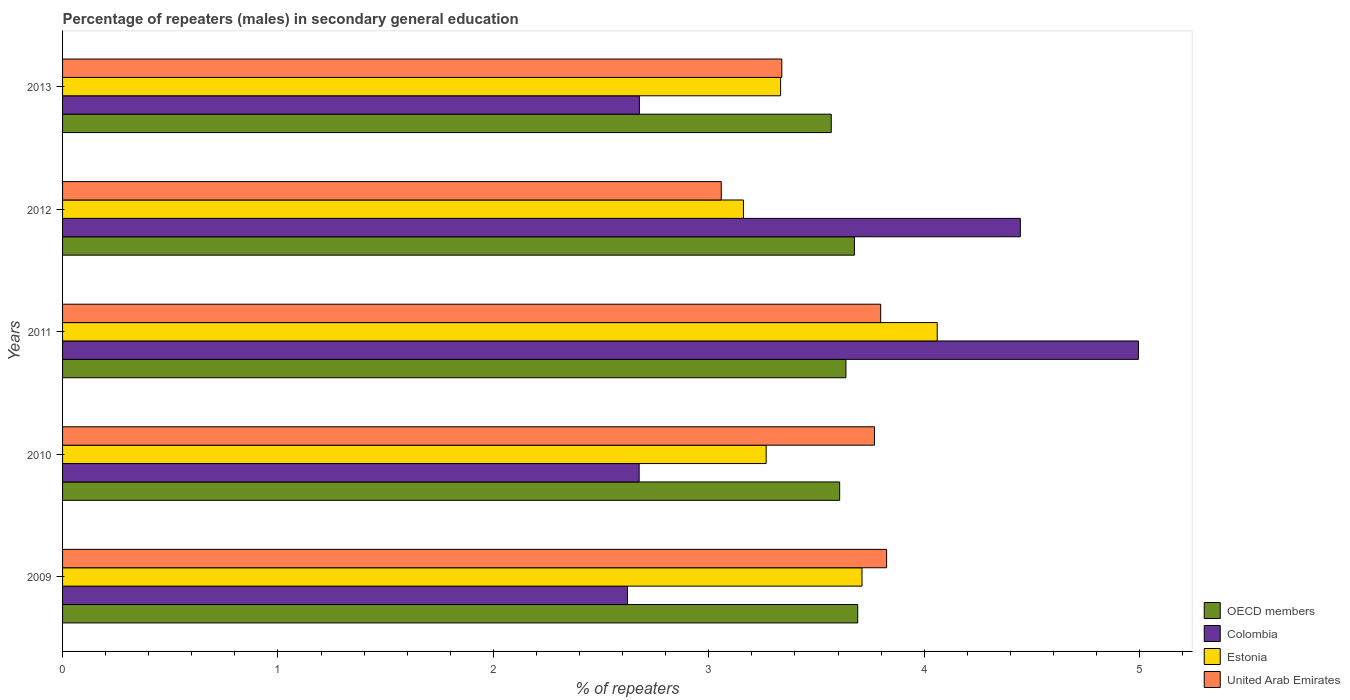How many groups of bars are there?
Offer a terse response. 5. Are the number of bars per tick equal to the number of legend labels?
Give a very brief answer. Yes. How many bars are there on the 2nd tick from the bottom?
Your answer should be compact. 4. What is the label of the 5th group of bars from the top?
Give a very brief answer. 2009. In how many cases, is the number of bars for a given year not equal to the number of legend labels?
Your response must be concise. 0. What is the percentage of male repeaters in United Arab Emirates in 2011?
Provide a short and direct response. 3.8. Across all years, what is the maximum percentage of male repeaters in OECD members?
Your response must be concise. 3.69. Across all years, what is the minimum percentage of male repeaters in Estonia?
Make the answer very short. 3.16. In which year was the percentage of male repeaters in Colombia maximum?
Ensure brevity in your answer.  2011. In which year was the percentage of male repeaters in United Arab Emirates minimum?
Keep it short and to the point. 2012. What is the total percentage of male repeaters in Colombia in the graph?
Make the answer very short. 17.42. What is the difference between the percentage of male repeaters in Estonia in 2011 and that in 2012?
Give a very brief answer. 0.9. What is the difference between the percentage of male repeaters in Colombia in 2009 and the percentage of male repeaters in Estonia in 2013?
Offer a very short reply. -0.71. What is the average percentage of male repeaters in OECD members per year?
Your answer should be compact. 3.64. In the year 2012, what is the difference between the percentage of male repeaters in Estonia and percentage of male repeaters in OECD members?
Provide a succinct answer. -0.52. In how many years, is the percentage of male repeaters in Colombia greater than 3.6 %?
Provide a succinct answer. 2. What is the ratio of the percentage of male repeaters in OECD members in 2011 to that in 2012?
Give a very brief answer. 0.99. Is the percentage of male repeaters in Estonia in 2009 less than that in 2011?
Keep it short and to the point. Yes. Is the difference between the percentage of male repeaters in Estonia in 2010 and 2013 greater than the difference between the percentage of male repeaters in OECD members in 2010 and 2013?
Offer a very short reply. No. What is the difference between the highest and the second highest percentage of male repeaters in Estonia?
Provide a short and direct response. 0.35. What is the difference between the highest and the lowest percentage of male repeaters in United Arab Emirates?
Offer a very short reply. 0.77. Is the sum of the percentage of male repeaters in Colombia in 2009 and 2011 greater than the maximum percentage of male repeaters in United Arab Emirates across all years?
Keep it short and to the point. Yes. What does the 1st bar from the top in 2009 represents?
Provide a succinct answer. United Arab Emirates. What does the 4th bar from the bottom in 2009 represents?
Your answer should be compact. United Arab Emirates. Are all the bars in the graph horizontal?
Keep it short and to the point. Yes. How many years are there in the graph?
Your answer should be very brief. 5. Are the values on the major ticks of X-axis written in scientific E-notation?
Provide a short and direct response. No. Does the graph contain any zero values?
Your answer should be very brief. No. Does the graph contain grids?
Provide a short and direct response. No. Where does the legend appear in the graph?
Offer a very short reply. Bottom right. How many legend labels are there?
Make the answer very short. 4. How are the legend labels stacked?
Your answer should be very brief. Vertical. What is the title of the graph?
Make the answer very short. Percentage of repeaters (males) in secondary general education. Does "Cameroon" appear as one of the legend labels in the graph?
Provide a succinct answer. No. What is the label or title of the X-axis?
Keep it short and to the point. % of repeaters. What is the label or title of the Y-axis?
Offer a terse response. Years. What is the % of repeaters of OECD members in 2009?
Your answer should be compact. 3.69. What is the % of repeaters in Colombia in 2009?
Ensure brevity in your answer.  2.62. What is the % of repeaters of Estonia in 2009?
Provide a short and direct response. 3.71. What is the % of repeaters in United Arab Emirates in 2009?
Offer a very short reply. 3.83. What is the % of repeaters in OECD members in 2010?
Provide a succinct answer. 3.61. What is the % of repeaters in Colombia in 2010?
Make the answer very short. 2.68. What is the % of repeaters of Estonia in 2010?
Provide a short and direct response. 3.27. What is the % of repeaters in United Arab Emirates in 2010?
Keep it short and to the point. 3.77. What is the % of repeaters of OECD members in 2011?
Ensure brevity in your answer.  3.64. What is the % of repeaters of Colombia in 2011?
Offer a terse response. 4.99. What is the % of repeaters of Estonia in 2011?
Your response must be concise. 4.06. What is the % of repeaters of United Arab Emirates in 2011?
Ensure brevity in your answer.  3.8. What is the % of repeaters in OECD members in 2012?
Your answer should be very brief. 3.68. What is the % of repeaters of Colombia in 2012?
Your answer should be compact. 4.45. What is the % of repeaters in Estonia in 2012?
Make the answer very short. 3.16. What is the % of repeaters in United Arab Emirates in 2012?
Make the answer very short. 3.06. What is the % of repeaters in OECD members in 2013?
Your response must be concise. 3.57. What is the % of repeaters in Colombia in 2013?
Offer a terse response. 2.68. What is the % of repeaters of Estonia in 2013?
Give a very brief answer. 3.33. What is the % of repeaters in United Arab Emirates in 2013?
Provide a short and direct response. 3.34. Across all years, what is the maximum % of repeaters of OECD members?
Offer a terse response. 3.69. Across all years, what is the maximum % of repeaters of Colombia?
Make the answer very short. 4.99. Across all years, what is the maximum % of repeaters of Estonia?
Offer a terse response. 4.06. Across all years, what is the maximum % of repeaters in United Arab Emirates?
Ensure brevity in your answer.  3.83. Across all years, what is the minimum % of repeaters of OECD members?
Your answer should be compact. 3.57. Across all years, what is the minimum % of repeaters in Colombia?
Give a very brief answer. 2.62. Across all years, what is the minimum % of repeaters in Estonia?
Ensure brevity in your answer.  3.16. Across all years, what is the minimum % of repeaters of United Arab Emirates?
Make the answer very short. 3.06. What is the total % of repeaters of OECD members in the graph?
Make the answer very short. 18.18. What is the total % of repeaters in Colombia in the graph?
Your response must be concise. 17.42. What is the total % of repeaters in Estonia in the graph?
Offer a terse response. 17.53. What is the total % of repeaters in United Arab Emirates in the graph?
Provide a succinct answer. 17.79. What is the difference between the % of repeaters of OECD members in 2009 and that in 2010?
Offer a very short reply. 0.08. What is the difference between the % of repeaters of Colombia in 2009 and that in 2010?
Provide a short and direct response. -0.05. What is the difference between the % of repeaters of Estonia in 2009 and that in 2010?
Provide a succinct answer. 0.44. What is the difference between the % of repeaters of United Arab Emirates in 2009 and that in 2010?
Give a very brief answer. 0.06. What is the difference between the % of repeaters in OECD members in 2009 and that in 2011?
Your response must be concise. 0.05. What is the difference between the % of repeaters of Colombia in 2009 and that in 2011?
Keep it short and to the point. -2.37. What is the difference between the % of repeaters of Estonia in 2009 and that in 2011?
Your response must be concise. -0.35. What is the difference between the % of repeaters of United Arab Emirates in 2009 and that in 2011?
Offer a terse response. 0.03. What is the difference between the % of repeaters of OECD members in 2009 and that in 2012?
Your answer should be compact. 0.02. What is the difference between the % of repeaters of Colombia in 2009 and that in 2012?
Your answer should be compact. -1.82. What is the difference between the % of repeaters of Estonia in 2009 and that in 2012?
Give a very brief answer. 0.55. What is the difference between the % of repeaters in United Arab Emirates in 2009 and that in 2012?
Offer a very short reply. 0.77. What is the difference between the % of repeaters in OECD members in 2009 and that in 2013?
Keep it short and to the point. 0.12. What is the difference between the % of repeaters in Colombia in 2009 and that in 2013?
Keep it short and to the point. -0.06. What is the difference between the % of repeaters of Estonia in 2009 and that in 2013?
Provide a short and direct response. 0.38. What is the difference between the % of repeaters in United Arab Emirates in 2009 and that in 2013?
Your response must be concise. 0.49. What is the difference between the % of repeaters of OECD members in 2010 and that in 2011?
Give a very brief answer. -0.03. What is the difference between the % of repeaters in Colombia in 2010 and that in 2011?
Give a very brief answer. -2.32. What is the difference between the % of repeaters in Estonia in 2010 and that in 2011?
Offer a terse response. -0.79. What is the difference between the % of repeaters in United Arab Emirates in 2010 and that in 2011?
Give a very brief answer. -0.03. What is the difference between the % of repeaters of OECD members in 2010 and that in 2012?
Keep it short and to the point. -0.07. What is the difference between the % of repeaters in Colombia in 2010 and that in 2012?
Your response must be concise. -1.77. What is the difference between the % of repeaters of Estonia in 2010 and that in 2012?
Keep it short and to the point. 0.11. What is the difference between the % of repeaters of United Arab Emirates in 2010 and that in 2012?
Offer a terse response. 0.71. What is the difference between the % of repeaters of OECD members in 2010 and that in 2013?
Your response must be concise. 0.04. What is the difference between the % of repeaters of Colombia in 2010 and that in 2013?
Your answer should be very brief. -0. What is the difference between the % of repeaters of Estonia in 2010 and that in 2013?
Your answer should be very brief. -0.07. What is the difference between the % of repeaters of United Arab Emirates in 2010 and that in 2013?
Your answer should be compact. 0.43. What is the difference between the % of repeaters of OECD members in 2011 and that in 2012?
Offer a terse response. -0.04. What is the difference between the % of repeaters in Colombia in 2011 and that in 2012?
Make the answer very short. 0.55. What is the difference between the % of repeaters of Estonia in 2011 and that in 2012?
Keep it short and to the point. 0.9. What is the difference between the % of repeaters of United Arab Emirates in 2011 and that in 2012?
Your response must be concise. 0.74. What is the difference between the % of repeaters of OECD members in 2011 and that in 2013?
Keep it short and to the point. 0.07. What is the difference between the % of repeaters in Colombia in 2011 and that in 2013?
Offer a very short reply. 2.32. What is the difference between the % of repeaters of Estonia in 2011 and that in 2013?
Your response must be concise. 0.73. What is the difference between the % of repeaters in United Arab Emirates in 2011 and that in 2013?
Ensure brevity in your answer.  0.46. What is the difference between the % of repeaters of OECD members in 2012 and that in 2013?
Provide a short and direct response. 0.11. What is the difference between the % of repeaters of Colombia in 2012 and that in 2013?
Offer a very short reply. 1.77. What is the difference between the % of repeaters in Estonia in 2012 and that in 2013?
Make the answer very short. -0.17. What is the difference between the % of repeaters of United Arab Emirates in 2012 and that in 2013?
Your response must be concise. -0.28. What is the difference between the % of repeaters of OECD members in 2009 and the % of repeaters of Colombia in 2010?
Give a very brief answer. 1.01. What is the difference between the % of repeaters in OECD members in 2009 and the % of repeaters in Estonia in 2010?
Keep it short and to the point. 0.43. What is the difference between the % of repeaters in OECD members in 2009 and the % of repeaters in United Arab Emirates in 2010?
Provide a short and direct response. -0.08. What is the difference between the % of repeaters in Colombia in 2009 and the % of repeaters in Estonia in 2010?
Provide a succinct answer. -0.64. What is the difference between the % of repeaters in Colombia in 2009 and the % of repeaters in United Arab Emirates in 2010?
Your answer should be very brief. -1.15. What is the difference between the % of repeaters in Estonia in 2009 and the % of repeaters in United Arab Emirates in 2010?
Your answer should be compact. -0.06. What is the difference between the % of repeaters in OECD members in 2009 and the % of repeaters in Colombia in 2011?
Provide a succinct answer. -1.3. What is the difference between the % of repeaters in OECD members in 2009 and the % of repeaters in Estonia in 2011?
Make the answer very short. -0.37. What is the difference between the % of repeaters in OECD members in 2009 and the % of repeaters in United Arab Emirates in 2011?
Offer a terse response. -0.11. What is the difference between the % of repeaters of Colombia in 2009 and the % of repeaters of Estonia in 2011?
Offer a terse response. -1.44. What is the difference between the % of repeaters of Colombia in 2009 and the % of repeaters of United Arab Emirates in 2011?
Your answer should be compact. -1.18. What is the difference between the % of repeaters of Estonia in 2009 and the % of repeaters of United Arab Emirates in 2011?
Make the answer very short. -0.09. What is the difference between the % of repeaters of OECD members in 2009 and the % of repeaters of Colombia in 2012?
Make the answer very short. -0.76. What is the difference between the % of repeaters of OECD members in 2009 and the % of repeaters of Estonia in 2012?
Your response must be concise. 0.53. What is the difference between the % of repeaters of OECD members in 2009 and the % of repeaters of United Arab Emirates in 2012?
Ensure brevity in your answer.  0.63. What is the difference between the % of repeaters in Colombia in 2009 and the % of repeaters in Estonia in 2012?
Your response must be concise. -0.54. What is the difference between the % of repeaters in Colombia in 2009 and the % of repeaters in United Arab Emirates in 2012?
Provide a succinct answer. -0.44. What is the difference between the % of repeaters in Estonia in 2009 and the % of repeaters in United Arab Emirates in 2012?
Offer a terse response. 0.65. What is the difference between the % of repeaters of OECD members in 2009 and the % of repeaters of Colombia in 2013?
Keep it short and to the point. 1.01. What is the difference between the % of repeaters of OECD members in 2009 and the % of repeaters of Estonia in 2013?
Give a very brief answer. 0.36. What is the difference between the % of repeaters in OECD members in 2009 and the % of repeaters in United Arab Emirates in 2013?
Provide a succinct answer. 0.35. What is the difference between the % of repeaters in Colombia in 2009 and the % of repeaters in Estonia in 2013?
Keep it short and to the point. -0.71. What is the difference between the % of repeaters of Colombia in 2009 and the % of repeaters of United Arab Emirates in 2013?
Your answer should be very brief. -0.72. What is the difference between the % of repeaters in Estonia in 2009 and the % of repeaters in United Arab Emirates in 2013?
Offer a terse response. 0.37. What is the difference between the % of repeaters in OECD members in 2010 and the % of repeaters in Colombia in 2011?
Ensure brevity in your answer.  -1.39. What is the difference between the % of repeaters of OECD members in 2010 and the % of repeaters of Estonia in 2011?
Offer a very short reply. -0.45. What is the difference between the % of repeaters in OECD members in 2010 and the % of repeaters in United Arab Emirates in 2011?
Provide a short and direct response. -0.19. What is the difference between the % of repeaters in Colombia in 2010 and the % of repeaters in Estonia in 2011?
Your answer should be very brief. -1.38. What is the difference between the % of repeaters in Colombia in 2010 and the % of repeaters in United Arab Emirates in 2011?
Ensure brevity in your answer.  -1.12. What is the difference between the % of repeaters of Estonia in 2010 and the % of repeaters of United Arab Emirates in 2011?
Provide a succinct answer. -0.53. What is the difference between the % of repeaters of OECD members in 2010 and the % of repeaters of Colombia in 2012?
Your answer should be very brief. -0.84. What is the difference between the % of repeaters in OECD members in 2010 and the % of repeaters in Estonia in 2012?
Offer a terse response. 0.45. What is the difference between the % of repeaters in OECD members in 2010 and the % of repeaters in United Arab Emirates in 2012?
Your answer should be very brief. 0.55. What is the difference between the % of repeaters of Colombia in 2010 and the % of repeaters of Estonia in 2012?
Your answer should be compact. -0.48. What is the difference between the % of repeaters in Colombia in 2010 and the % of repeaters in United Arab Emirates in 2012?
Offer a terse response. -0.38. What is the difference between the % of repeaters of Estonia in 2010 and the % of repeaters of United Arab Emirates in 2012?
Offer a terse response. 0.21. What is the difference between the % of repeaters in OECD members in 2010 and the % of repeaters in Colombia in 2013?
Offer a terse response. 0.93. What is the difference between the % of repeaters in OECD members in 2010 and the % of repeaters in Estonia in 2013?
Make the answer very short. 0.27. What is the difference between the % of repeaters in OECD members in 2010 and the % of repeaters in United Arab Emirates in 2013?
Your answer should be compact. 0.27. What is the difference between the % of repeaters in Colombia in 2010 and the % of repeaters in Estonia in 2013?
Your answer should be very brief. -0.66. What is the difference between the % of repeaters in Colombia in 2010 and the % of repeaters in United Arab Emirates in 2013?
Make the answer very short. -0.66. What is the difference between the % of repeaters of Estonia in 2010 and the % of repeaters of United Arab Emirates in 2013?
Provide a short and direct response. -0.07. What is the difference between the % of repeaters in OECD members in 2011 and the % of repeaters in Colombia in 2012?
Your answer should be very brief. -0.81. What is the difference between the % of repeaters of OECD members in 2011 and the % of repeaters of Estonia in 2012?
Your answer should be very brief. 0.48. What is the difference between the % of repeaters in OECD members in 2011 and the % of repeaters in United Arab Emirates in 2012?
Ensure brevity in your answer.  0.58. What is the difference between the % of repeaters of Colombia in 2011 and the % of repeaters of Estonia in 2012?
Your answer should be compact. 1.83. What is the difference between the % of repeaters of Colombia in 2011 and the % of repeaters of United Arab Emirates in 2012?
Ensure brevity in your answer.  1.94. What is the difference between the % of repeaters of Estonia in 2011 and the % of repeaters of United Arab Emirates in 2012?
Offer a terse response. 1. What is the difference between the % of repeaters of OECD members in 2011 and the % of repeaters of Colombia in 2013?
Make the answer very short. 0.96. What is the difference between the % of repeaters of OECD members in 2011 and the % of repeaters of Estonia in 2013?
Offer a very short reply. 0.3. What is the difference between the % of repeaters of OECD members in 2011 and the % of repeaters of United Arab Emirates in 2013?
Provide a succinct answer. 0.3. What is the difference between the % of repeaters of Colombia in 2011 and the % of repeaters of Estonia in 2013?
Offer a very short reply. 1.66. What is the difference between the % of repeaters in Colombia in 2011 and the % of repeaters in United Arab Emirates in 2013?
Give a very brief answer. 1.66. What is the difference between the % of repeaters in Estonia in 2011 and the % of repeaters in United Arab Emirates in 2013?
Your answer should be compact. 0.72. What is the difference between the % of repeaters in OECD members in 2012 and the % of repeaters in Estonia in 2013?
Your response must be concise. 0.34. What is the difference between the % of repeaters of OECD members in 2012 and the % of repeaters of United Arab Emirates in 2013?
Provide a short and direct response. 0.34. What is the difference between the % of repeaters of Colombia in 2012 and the % of repeaters of Estonia in 2013?
Offer a terse response. 1.11. What is the difference between the % of repeaters of Colombia in 2012 and the % of repeaters of United Arab Emirates in 2013?
Make the answer very short. 1.11. What is the difference between the % of repeaters of Estonia in 2012 and the % of repeaters of United Arab Emirates in 2013?
Make the answer very short. -0.18. What is the average % of repeaters in OECD members per year?
Your answer should be very brief. 3.64. What is the average % of repeaters of Colombia per year?
Keep it short and to the point. 3.48. What is the average % of repeaters in Estonia per year?
Your response must be concise. 3.51. What is the average % of repeaters in United Arab Emirates per year?
Offer a very short reply. 3.56. In the year 2009, what is the difference between the % of repeaters of OECD members and % of repeaters of Colombia?
Provide a short and direct response. 1.07. In the year 2009, what is the difference between the % of repeaters in OECD members and % of repeaters in Estonia?
Offer a very short reply. -0.02. In the year 2009, what is the difference between the % of repeaters of OECD members and % of repeaters of United Arab Emirates?
Your response must be concise. -0.13. In the year 2009, what is the difference between the % of repeaters in Colombia and % of repeaters in Estonia?
Your response must be concise. -1.09. In the year 2009, what is the difference between the % of repeaters in Colombia and % of repeaters in United Arab Emirates?
Your answer should be very brief. -1.2. In the year 2009, what is the difference between the % of repeaters in Estonia and % of repeaters in United Arab Emirates?
Ensure brevity in your answer.  -0.11. In the year 2010, what is the difference between the % of repeaters in OECD members and % of repeaters in Colombia?
Give a very brief answer. 0.93. In the year 2010, what is the difference between the % of repeaters in OECD members and % of repeaters in Estonia?
Your answer should be compact. 0.34. In the year 2010, what is the difference between the % of repeaters of OECD members and % of repeaters of United Arab Emirates?
Ensure brevity in your answer.  -0.16. In the year 2010, what is the difference between the % of repeaters of Colombia and % of repeaters of Estonia?
Make the answer very short. -0.59. In the year 2010, what is the difference between the % of repeaters in Colombia and % of repeaters in United Arab Emirates?
Your response must be concise. -1.09. In the year 2010, what is the difference between the % of repeaters of Estonia and % of repeaters of United Arab Emirates?
Your response must be concise. -0.5. In the year 2011, what is the difference between the % of repeaters of OECD members and % of repeaters of Colombia?
Make the answer very short. -1.36. In the year 2011, what is the difference between the % of repeaters in OECD members and % of repeaters in Estonia?
Give a very brief answer. -0.42. In the year 2011, what is the difference between the % of repeaters in OECD members and % of repeaters in United Arab Emirates?
Offer a very short reply. -0.16. In the year 2011, what is the difference between the % of repeaters of Colombia and % of repeaters of Estonia?
Keep it short and to the point. 0.93. In the year 2011, what is the difference between the % of repeaters in Colombia and % of repeaters in United Arab Emirates?
Ensure brevity in your answer.  1.2. In the year 2011, what is the difference between the % of repeaters in Estonia and % of repeaters in United Arab Emirates?
Give a very brief answer. 0.26. In the year 2012, what is the difference between the % of repeaters of OECD members and % of repeaters of Colombia?
Give a very brief answer. -0.77. In the year 2012, what is the difference between the % of repeaters in OECD members and % of repeaters in Estonia?
Offer a terse response. 0.52. In the year 2012, what is the difference between the % of repeaters in OECD members and % of repeaters in United Arab Emirates?
Your response must be concise. 0.62. In the year 2012, what is the difference between the % of repeaters in Colombia and % of repeaters in Estonia?
Offer a terse response. 1.29. In the year 2012, what is the difference between the % of repeaters of Colombia and % of repeaters of United Arab Emirates?
Ensure brevity in your answer.  1.39. In the year 2012, what is the difference between the % of repeaters of Estonia and % of repeaters of United Arab Emirates?
Ensure brevity in your answer.  0.1. In the year 2013, what is the difference between the % of repeaters in OECD members and % of repeaters in Colombia?
Keep it short and to the point. 0.89. In the year 2013, what is the difference between the % of repeaters in OECD members and % of repeaters in Estonia?
Provide a succinct answer. 0.24. In the year 2013, what is the difference between the % of repeaters in OECD members and % of repeaters in United Arab Emirates?
Offer a terse response. 0.23. In the year 2013, what is the difference between the % of repeaters in Colombia and % of repeaters in Estonia?
Provide a short and direct response. -0.66. In the year 2013, what is the difference between the % of repeaters of Colombia and % of repeaters of United Arab Emirates?
Provide a short and direct response. -0.66. In the year 2013, what is the difference between the % of repeaters of Estonia and % of repeaters of United Arab Emirates?
Provide a short and direct response. -0.01. What is the ratio of the % of repeaters of OECD members in 2009 to that in 2010?
Provide a short and direct response. 1.02. What is the ratio of the % of repeaters of Colombia in 2009 to that in 2010?
Make the answer very short. 0.98. What is the ratio of the % of repeaters in Estonia in 2009 to that in 2010?
Give a very brief answer. 1.14. What is the ratio of the % of repeaters of United Arab Emirates in 2009 to that in 2010?
Your answer should be compact. 1.01. What is the ratio of the % of repeaters of OECD members in 2009 to that in 2011?
Provide a succinct answer. 1.02. What is the ratio of the % of repeaters of Colombia in 2009 to that in 2011?
Offer a very short reply. 0.53. What is the ratio of the % of repeaters in Estonia in 2009 to that in 2011?
Your answer should be very brief. 0.91. What is the ratio of the % of repeaters of United Arab Emirates in 2009 to that in 2011?
Keep it short and to the point. 1.01. What is the ratio of the % of repeaters of OECD members in 2009 to that in 2012?
Provide a short and direct response. 1. What is the ratio of the % of repeaters of Colombia in 2009 to that in 2012?
Provide a succinct answer. 0.59. What is the ratio of the % of repeaters of Estonia in 2009 to that in 2012?
Provide a succinct answer. 1.17. What is the ratio of the % of repeaters in United Arab Emirates in 2009 to that in 2012?
Your answer should be very brief. 1.25. What is the ratio of the % of repeaters of OECD members in 2009 to that in 2013?
Keep it short and to the point. 1.03. What is the ratio of the % of repeaters in Colombia in 2009 to that in 2013?
Provide a succinct answer. 0.98. What is the ratio of the % of repeaters of Estonia in 2009 to that in 2013?
Your answer should be compact. 1.11. What is the ratio of the % of repeaters in United Arab Emirates in 2009 to that in 2013?
Ensure brevity in your answer.  1.15. What is the ratio of the % of repeaters in Colombia in 2010 to that in 2011?
Provide a succinct answer. 0.54. What is the ratio of the % of repeaters in Estonia in 2010 to that in 2011?
Your response must be concise. 0.8. What is the ratio of the % of repeaters in OECD members in 2010 to that in 2012?
Your answer should be compact. 0.98. What is the ratio of the % of repeaters of Colombia in 2010 to that in 2012?
Your answer should be very brief. 0.6. What is the ratio of the % of repeaters in Estonia in 2010 to that in 2012?
Give a very brief answer. 1.03. What is the ratio of the % of repeaters in United Arab Emirates in 2010 to that in 2012?
Offer a very short reply. 1.23. What is the ratio of the % of repeaters of OECD members in 2010 to that in 2013?
Ensure brevity in your answer.  1.01. What is the ratio of the % of repeaters in Colombia in 2010 to that in 2013?
Ensure brevity in your answer.  1. What is the ratio of the % of repeaters of Estonia in 2010 to that in 2013?
Ensure brevity in your answer.  0.98. What is the ratio of the % of repeaters of United Arab Emirates in 2010 to that in 2013?
Your answer should be compact. 1.13. What is the ratio of the % of repeaters of OECD members in 2011 to that in 2012?
Provide a short and direct response. 0.99. What is the ratio of the % of repeaters in Colombia in 2011 to that in 2012?
Your answer should be very brief. 1.12. What is the ratio of the % of repeaters in Estonia in 2011 to that in 2012?
Ensure brevity in your answer.  1.28. What is the ratio of the % of repeaters in United Arab Emirates in 2011 to that in 2012?
Provide a succinct answer. 1.24. What is the ratio of the % of repeaters in OECD members in 2011 to that in 2013?
Provide a succinct answer. 1.02. What is the ratio of the % of repeaters of Colombia in 2011 to that in 2013?
Your answer should be very brief. 1.87. What is the ratio of the % of repeaters of Estonia in 2011 to that in 2013?
Your answer should be compact. 1.22. What is the ratio of the % of repeaters of United Arab Emirates in 2011 to that in 2013?
Provide a short and direct response. 1.14. What is the ratio of the % of repeaters in OECD members in 2012 to that in 2013?
Provide a short and direct response. 1.03. What is the ratio of the % of repeaters of Colombia in 2012 to that in 2013?
Provide a short and direct response. 1.66. What is the ratio of the % of repeaters in Estonia in 2012 to that in 2013?
Your response must be concise. 0.95. What is the ratio of the % of repeaters in United Arab Emirates in 2012 to that in 2013?
Give a very brief answer. 0.92. What is the difference between the highest and the second highest % of repeaters of OECD members?
Your response must be concise. 0.02. What is the difference between the highest and the second highest % of repeaters in Colombia?
Make the answer very short. 0.55. What is the difference between the highest and the second highest % of repeaters in Estonia?
Offer a very short reply. 0.35. What is the difference between the highest and the second highest % of repeaters in United Arab Emirates?
Offer a terse response. 0.03. What is the difference between the highest and the lowest % of repeaters of OECD members?
Your response must be concise. 0.12. What is the difference between the highest and the lowest % of repeaters of Colombia?
Give a very brief answer. 2.37. What is the difference between the highest and the lowest % of repeaters in Estonia?
Keep it short and to the point. 0.9. What is the difference between the highest and the lowest % of repeaters in United Arab Emirates?
Keep it short and to the point. 0.77. 